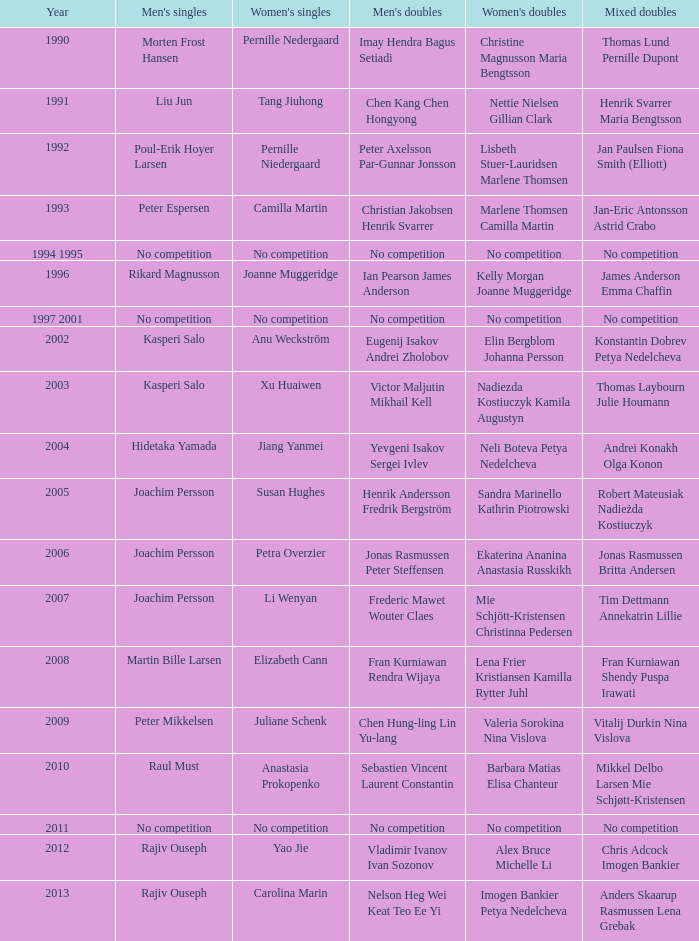Who won the Mixed doubles when Juliane Schenk won the Women's Singles? Vitalij Durkin Nina Vislova. 